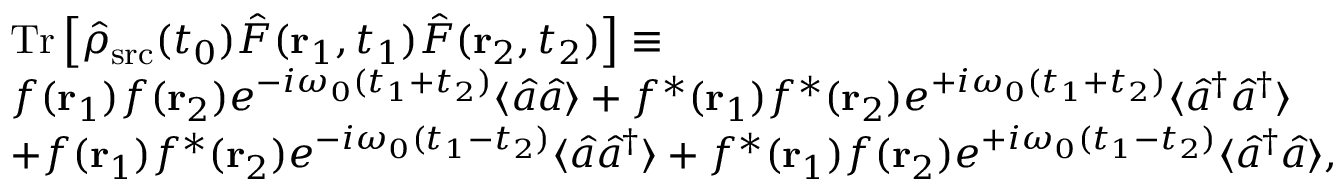<formula> <loc_0><loc_0><loc_500><loc_500>\begin{array} { r l } & { T r \left [ \hat { \rho } _ { s r c } ( t _ { 0 } ) \hat { F } ( { r } _ { 1 } , t _ { 1 } ) \hat { F } ( { r } _ { 2 } , t _ { 2 } ) \right ] \equiv } \\ & { f ( { r } _ { 1 } ) f ( { r } _ { 2 } ) e ^ { - i \omega _ { 0 } ( t _ { 1 } + t _ { 2 } ) } \langle \hat { a } \hat { a } \rangle + f ^ { \ast } ( { r } _ { 1 } ) f ^ { \ast } ( { r } _ { 2 } ) e ^ { + i \omega _ { 0 } ( t _ { 1 } + t _ { 2 } ) } \langle \hat { a } ^ { \dagger } \hat { a } ^ { \dagger } \rangle } \\ & { + f ( { r } _ { 1 } ) f ^ { \ast } ( { r } _ { 2 } ) e ^ { - i \omega _ { 0 } ( t _ { 1 } - t _ { 2 } ) } \langle \hat { a } \hat { a } ^ { \dagger } \rangle + f ^ { \ast } ( { r } _ { 1 } ) f ( { r } _ { 2 } ) e ^ { + i \omega _ { 0 } ( t _ { 1 } - t _ { 2 } ) } \langle \hat { a } ^ { \dagger } \hat { a } \rangle , } \end{array}</formula> 